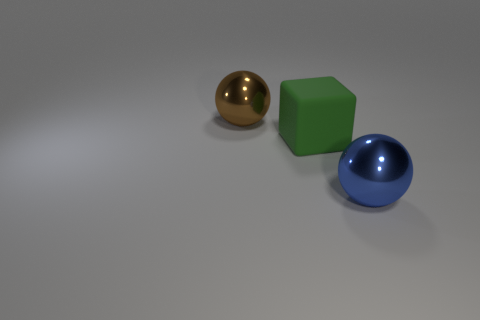Add 1 big green cubes. How many objects exist? 4 Subtract all spheres. How many objects are left? 1 Subtract all red spheres. Subtract all purple cylinders. How many spheres are left? 2 Subtract all blue balls. Subtract all green cubes. How many objects are left? 1 Add 2 big brown shiny spheres. How many big brown shiny spheres are left? 3 Add 2 big brown metallic cylinders. How many big brown metallic cylinders exist? 2 Subtract 0 yellow cylinders. How many objects are left? 3 